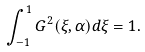Convert formula to latex. <formula><loc_0><loc_0><loc_500><loc_500>\int _ { - 1 } ^ { 1 } G ^ { 2 } ( \xi , \alpha ) d \xi = 1 .</formula> 